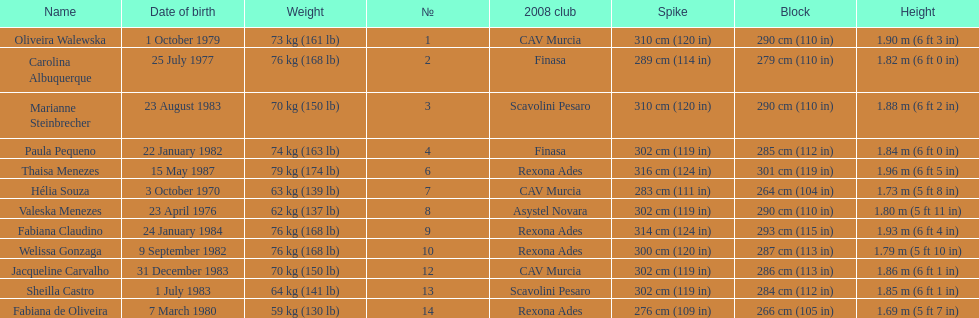Oliveira walewska has the same block as how many other players? 2. 